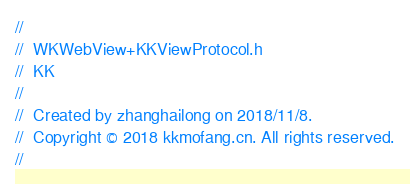<code> <loc_0><loc_0><loc_500><loc_500><_C_>//
//  WKWebView+KKViewProtocol.h
//  KK
//
//  Created by zhanghailong on 2018/11/8.
//  Copyright © 2018 kkmofang.cn. All rights reserved.
//
</code> 